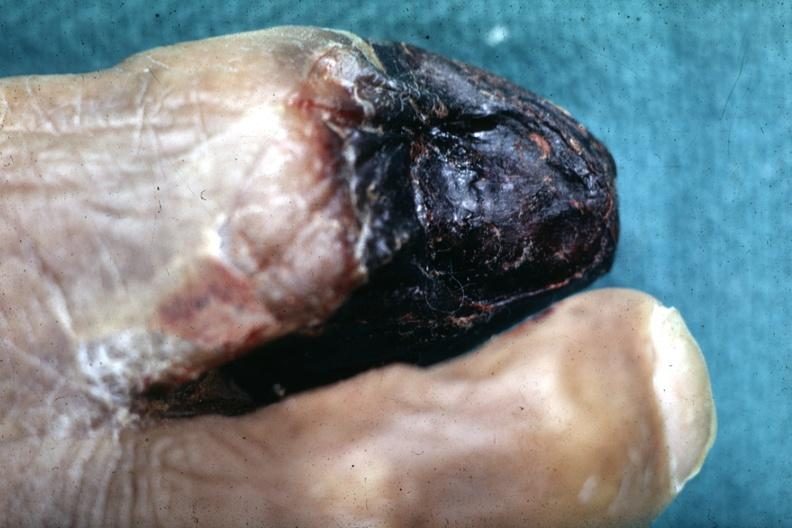does atherosclerosis show close-up view of gangrene?
Answer the question using a single word or phrase. No 